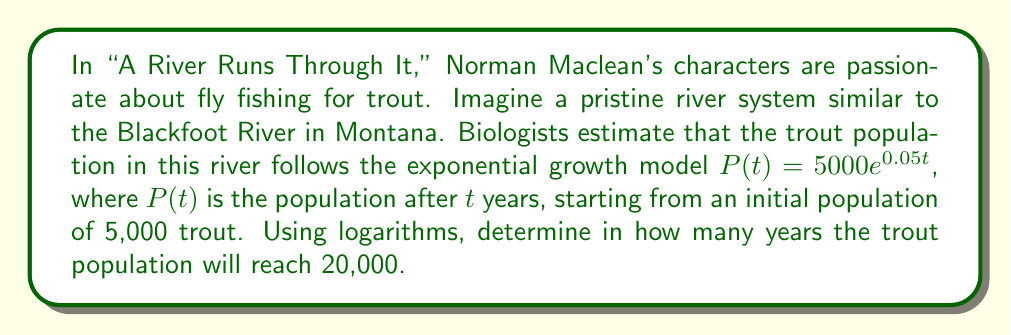What is the answer to this math problem? To solve this problem, we'll use the properties of logarithms and the given exponential growth model. Let's approach this step-by-step:

1) We start with the exponential growth model:
   $P(t) = 5000e^{0.05t}$

2) We want to find $t$ when $P(t) = 20,000$. So, we set up the equation:
   $20000 = 5000e^{0.05t}$

3) Divide both sides by 5000:
   $4 = e^{0.05t}$

4) Now, we can apply the natural logarithm (ln) to both sides. Remember, ln and e are inverse functions, so they cancel each other out on the right side:
   $\ln(4) = \ln(e^{0.05t})$
   $\ln(4) = 0.05t$

5) Solve for $t$ by dividing both sides by 0.05:
   $t = \frac{\ln(4)}{0.05}$

6) Calculate the value:
   $t = \frac{\ln(4)}{0.05} \approx 27.73$ years

Therefore, it will take approximately 27.73 years for the trout population to reach 20,000.

This problem illustrates how logarithms can be used to solve exponential equations, much like how Maclean's characters in "A River Runs Through It" needed to understand the river's ecosystem to become skilled fly fishermen.
Answer: $t = \frac{\ln(4)}{0.05} \approx 27.73$ years 